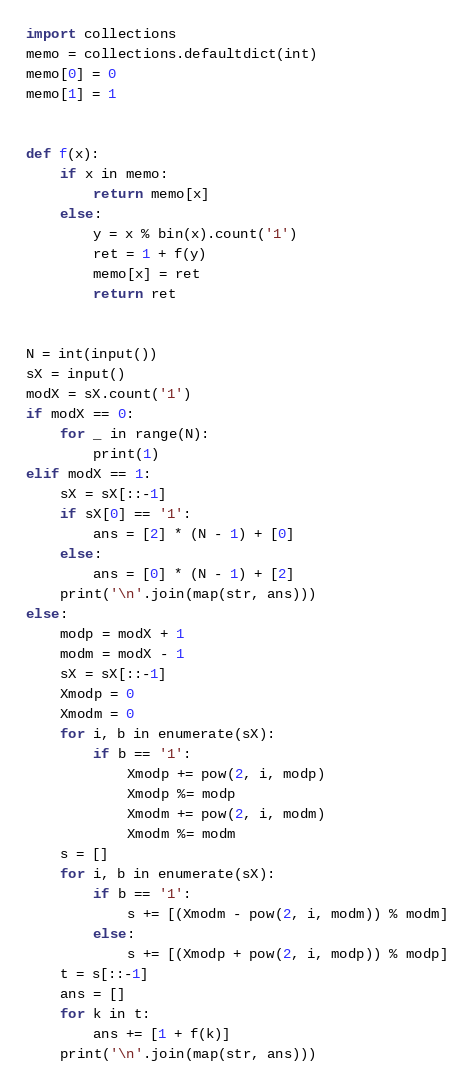<code> <loc_0><loc_0><loc_500><loc_500><_Python_>import collections
memo = collections.defaultdict(int)
memo[0] = 0
memo[1] = 1


def f(x):
    if x in memo:
        return memo[x]
    else:
        y = x % bin(x).count('1')
        ret = 1 + f(y)
        memo[x] = ret
        return ret


N = int(input())
sX = input()
modX = sX.count('1')
if modX == 0:
    for _ in range(N):
        print(1)
elif modX == 1:
    sX = sX[::-1]
    if sX[0] == '1':
        ans = [2] * (N - 1) + [0]
    else:
        ans = [0] * (N - 1) + [2]
    print('\n'.join(map(str, ans)))
else:
    modp = modX + 1
    modm = modX - 1
    sX = sX[::-1]
    Xmodp = 0
    Xmodm = 0
    for i, b in enumerate(sX):
        if b == '1':
            Xmodp += pow(2, i, modp)
            Xmodp %= modp
            Xmodm += pow(2, i, modm)
            Xmodm %= modm
    s = []
    for i, b in enumerate(sX):
        if b == '1':
            s += [(Xmodm - pow(2, i, modm)) % modm]
        else:
            s += [(Xmodp + pow(2, i, modp)) % modp]
    t = s[::-1]
    ans = []
    for k in t:
        ans += [1 + f(k)]
    print('\n'.join(map(str, ans)))
</code> 